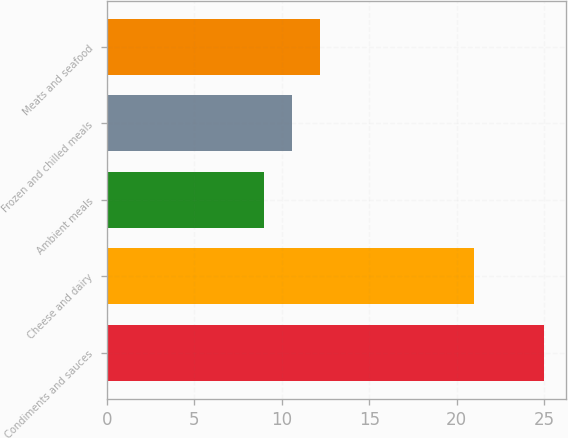Convert chart. <chart><loc_0><loc_0><loc_500><loc_500><bar_chart><fcel>Condiments and sauces<fcel>Cheese and dairy<fcel>Ambient meals<fcel>Frozen and chilled meals<fcel>Meats and seafood<nl><fcel>25<fcel>21<fcel>9<fcel>10.6<fcel>12.2<nl></chart> 